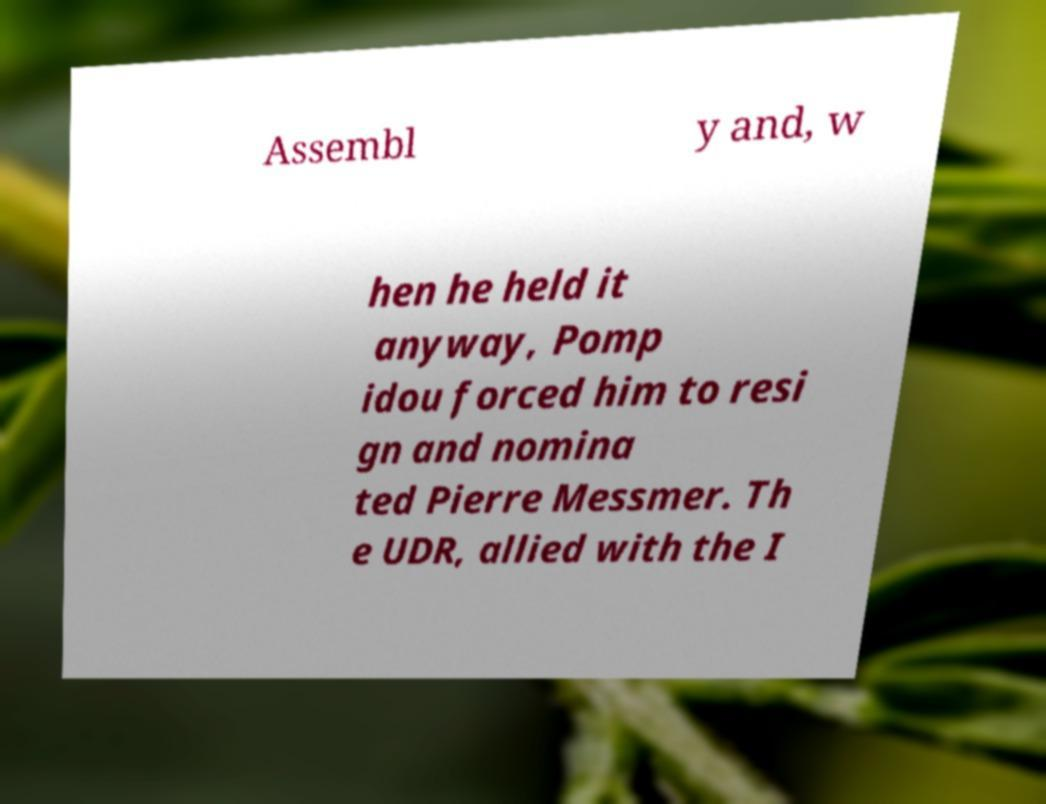For documentation purposes, I need the text within this image transcribed. Could you provide that? Assembl y and, w hen he held it anyway, Pomp idou forced him to resi gn and nomina ted Pierre Messmer. Th e UDR, allied with the I 